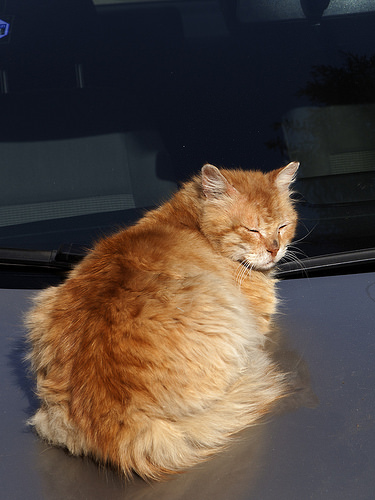<image>
Can you confirm if the cat is on the table? Yes. Looking at the image, I can see the cat is positioned on top of the table, with the table providing support. Is the cat above the table? No. The cat is not positioned above the table. The vertical arrangement shows a different relationship. 